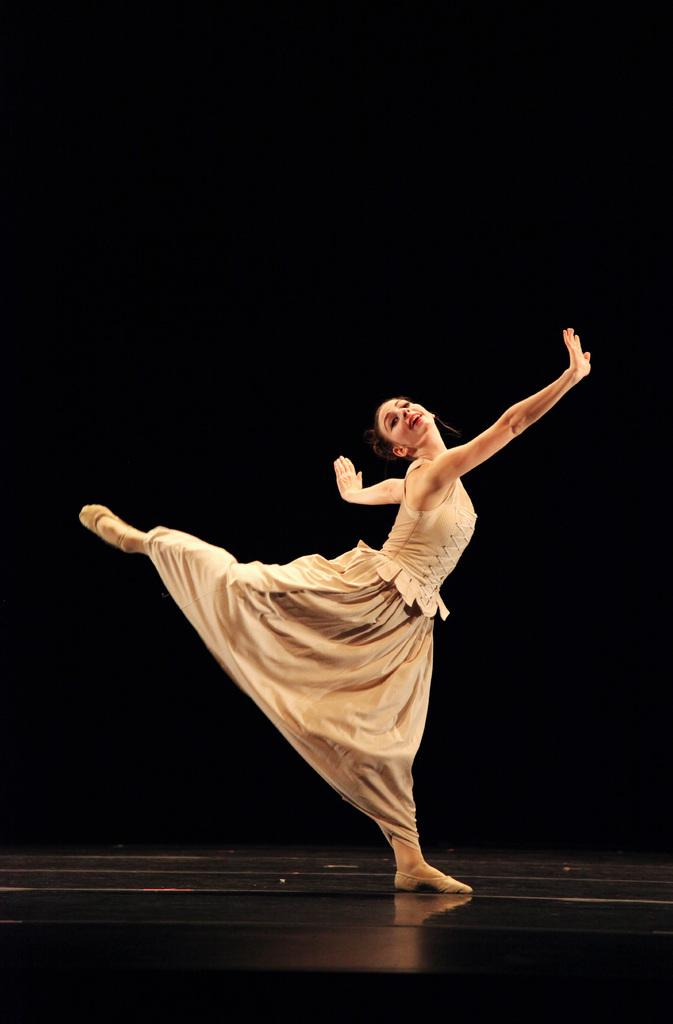Where was the image most likely taken? The image was likely taken indoors. What is the main subject of the image? There is a person in the center of the image. What is the person wearing? The person is wearing a frock. What is the person doing in the image? The person appears to be dancing. How would you describe the lighting in the image? The background of the image is dark. What type of treatment is the person receiving in the image? There is no indication in the image that the person is receiving any treatment. Can you tell me the title of the dance the person is performing in the image? The image does not provide a title for the dance being performed. 